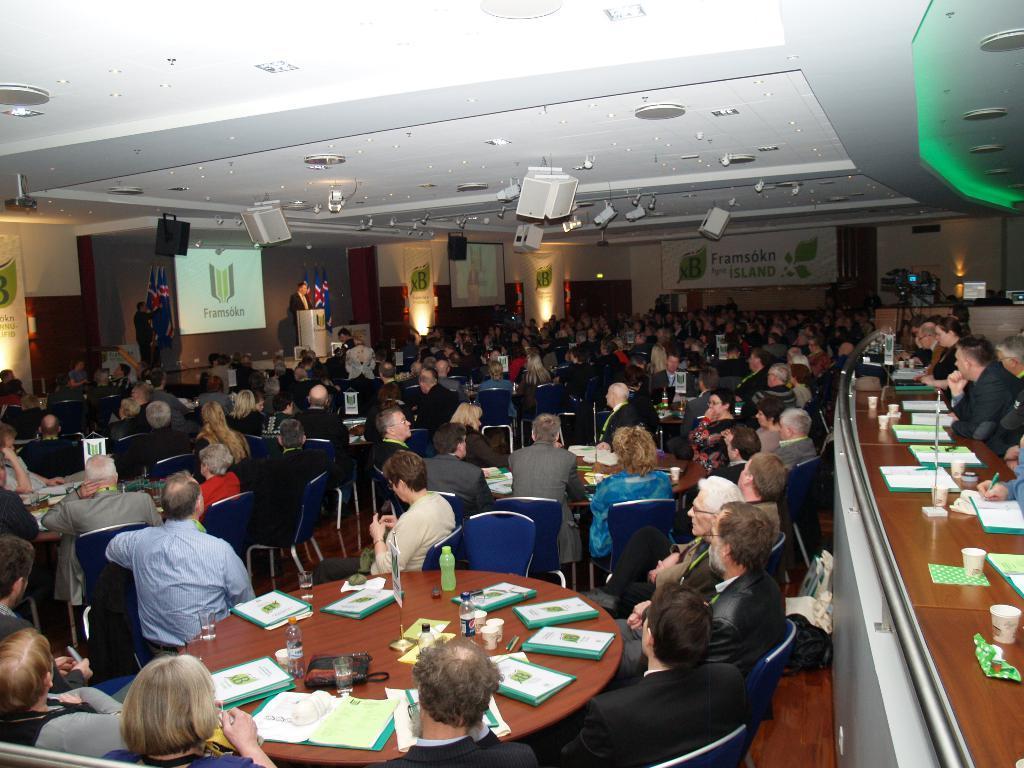Describe this image in one or two sentences. In the image we can see there are many people around, they are wearing clothes, they are sitting on the chair. There are even many tables and on the table there are files, water bottles, glasses and other object kept. There is a light projection screen, projector and banner. Here we can see a flag of the country and this is a wooden floor. 